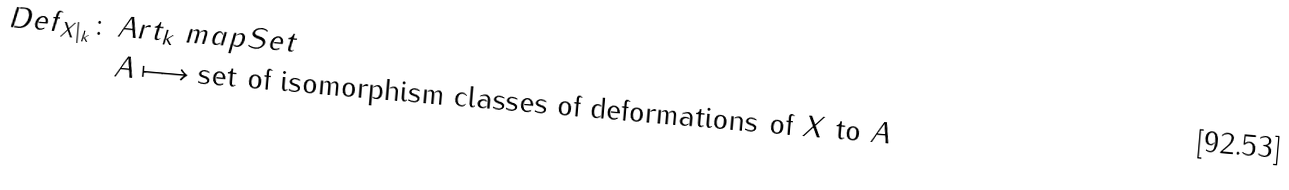<formula> <loc_0><loc_0><loc_500><loc_500>D e f _ { X | _ { k } } \colon \, & A r t _ { k } \ m a p S e t \\ & A \longmapsto \text {set of isomorphism classes of deformations       of $X$ to $A$}</formula> 